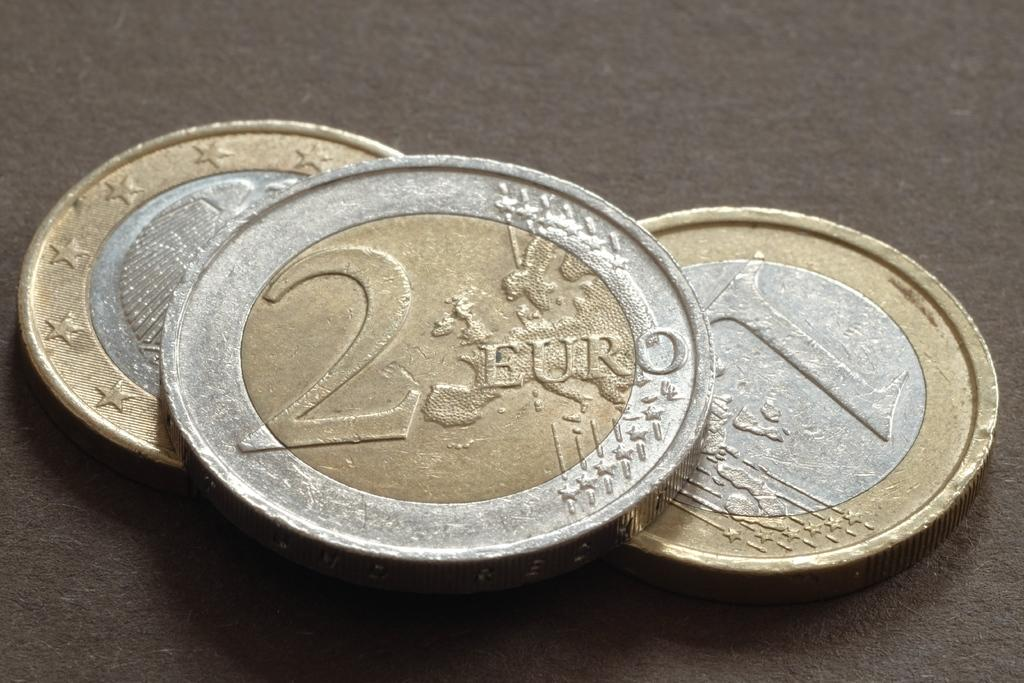<image>
Summarize the visual content of the image. A 2 Euro coin stacked on top of a 1 Euro coin, and another unidentified coin. 